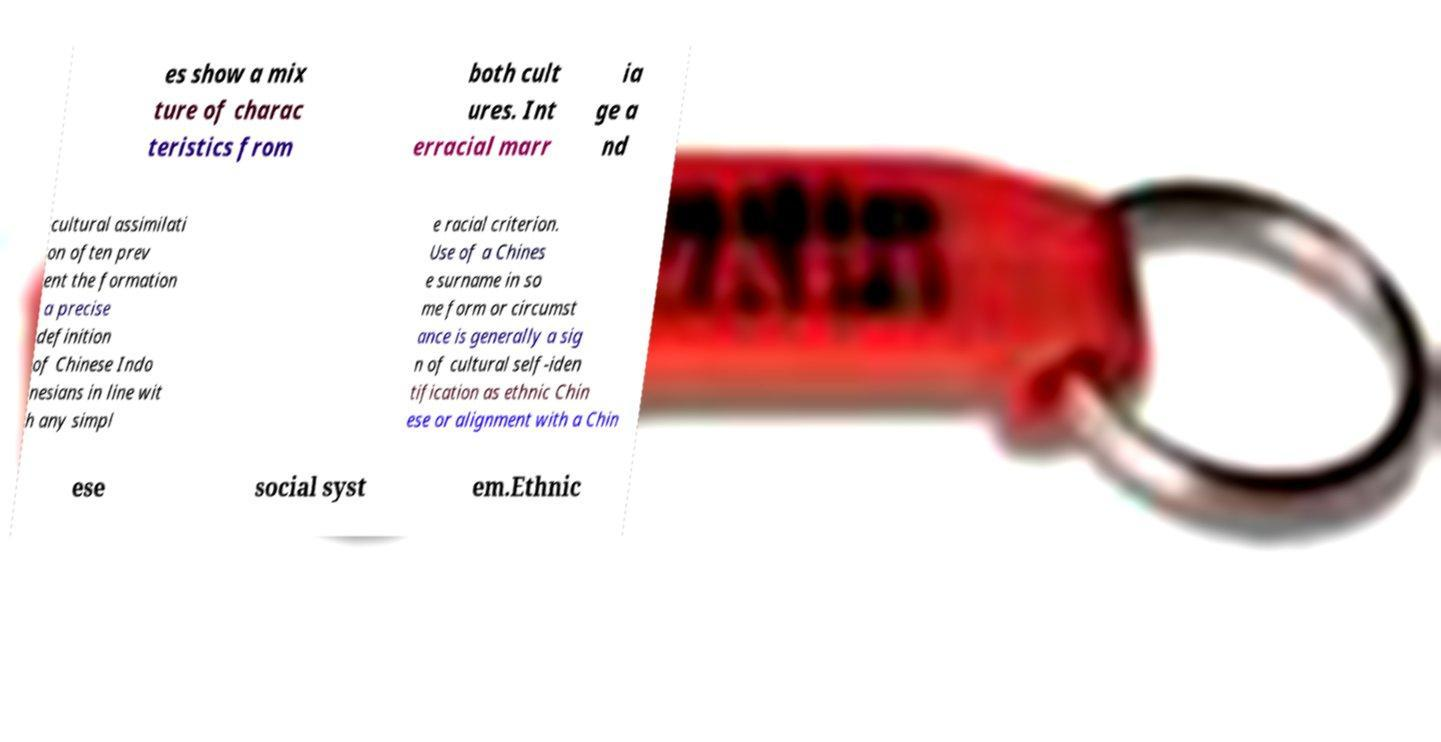Could you extract and type out the text from this image? es show a mix ture of charac teristics from both cult ures. Int erracial marr ia ge a nd cultural assimilati on often prev ent the formation a precise definition of Chinese Indo nesians in line wit h any simpl e racial criterion. Use of a Chines e surname in so me form or circumst ance is generally a sig n of cultural self-iden tification as ethnic Chin ese or alignment with a Chin ese social syst em.Ethnic 